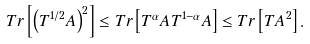Convert formula to latex. <formula><loc_0><loc_0><loc_500><loc_500>T r \left [ \left ( T ^ { 1 / 2 } A \right ) ^ { 2 } \right ] \leq T r \left [ T ^ { \alpha } A T ^ { 1 - \alpha } A \right ] \leq T r \left [ T A ^ { 2 } \right ] .</formula> 